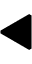<formula> <loc_0><loc_0><loc_500><loc_500>\blacktriangleleft</formula> 